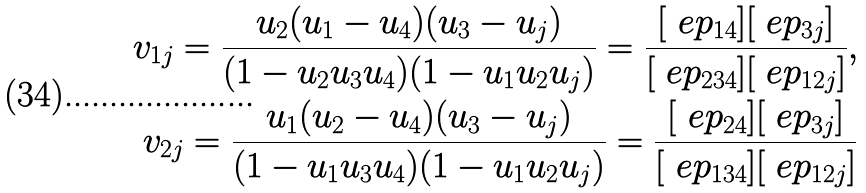<formula> <loc_0><loc_0><loc_500><loc_500>v _ { 1 j } = \frac { u _ { 2 } ( u _ { 1 } - u _ { 4 } ) ( u _ { 3 } - u _ { j } ) } { ( 1 - u _ { 2 } u _ { 3 } u _ { 4 } ) ( 1 - u _ { 1 } u _ { 2 } u _ { j } ) } = \frac { [ \ e p _ { 1 4 } ] [ \ e p _ { 3 j } ] } { [ \ e p _ { 2 3 4 } ] [ \ e p _ { 1 2 j } ] } , \\ v _ { 2 j } = \frac { u _ { 1 } ( u _ { 2 } - u _ { 4 } ) ( u _ { 3 } - u _ { j } ) } { ( 1 - u _ { 1 } u _ { 3 } u _ { 4 } ) ( 1 - u _ { 1 } u _ { 2 } u _ { j } ) } = \frac { [ \ e p _ { 2 4 } ] [ \ e p _ { 3 j } ] } { [ \ e p _ { 1 3 4 } ] [ \ e p _ { 1 2 j } ] }</formula> 